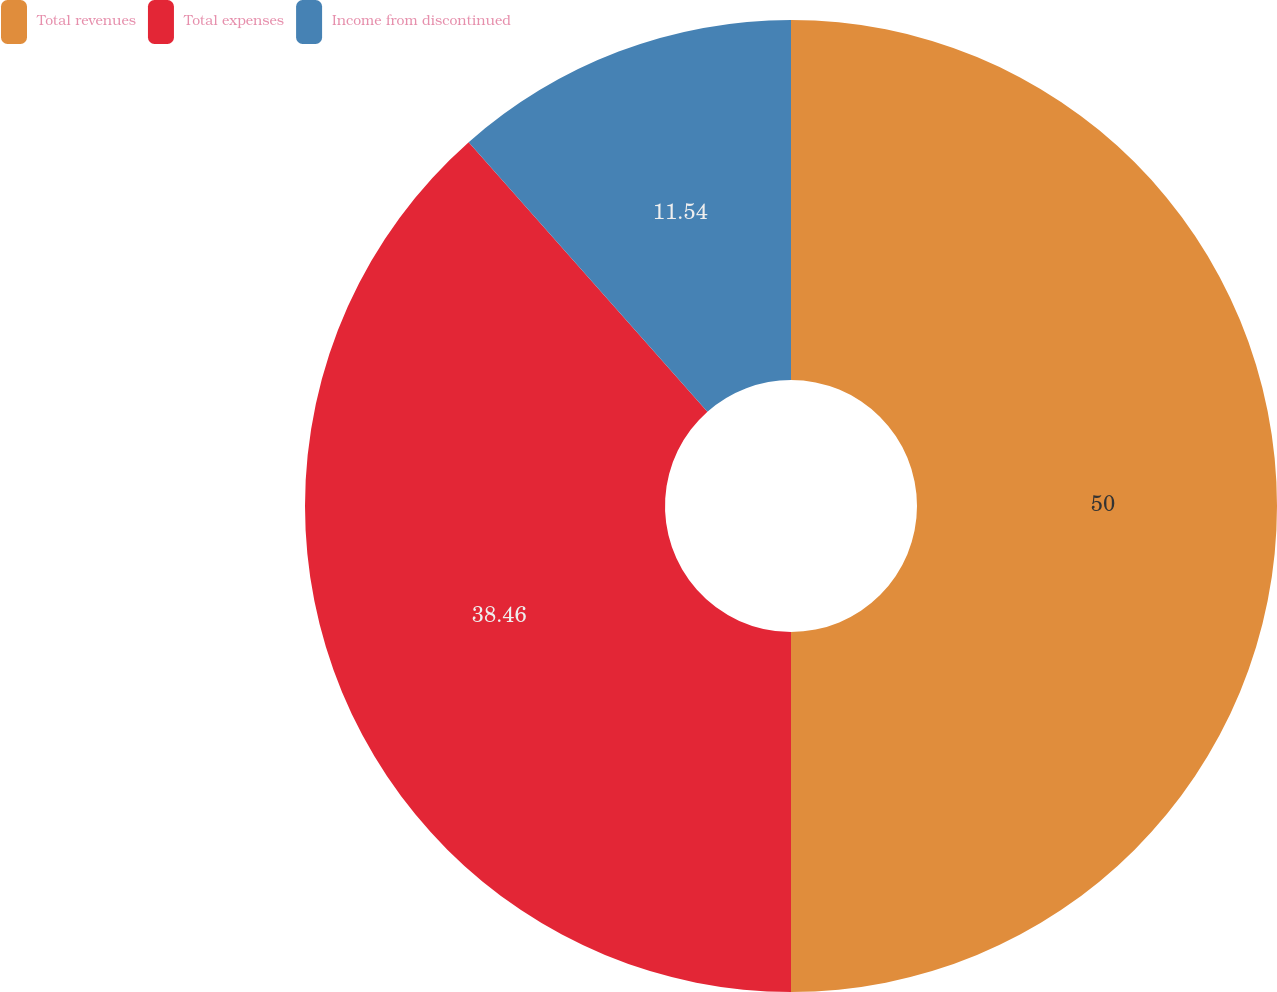<chart> <loc_0><loc_0><loc_500><loc_500><pie_chart><fcel>Total revenues<fcel>Total expenses<fcel>Income from discontinued<nl><fcel>50.0%<fcel>38.46%<fcel>11.54%<nl></chart> 